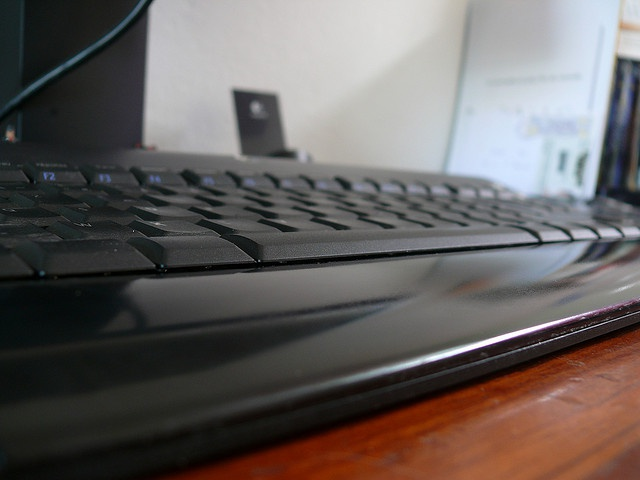Describe the objects in this image and their specific colors. I can see a keyboard in black and gray tones in this image. 